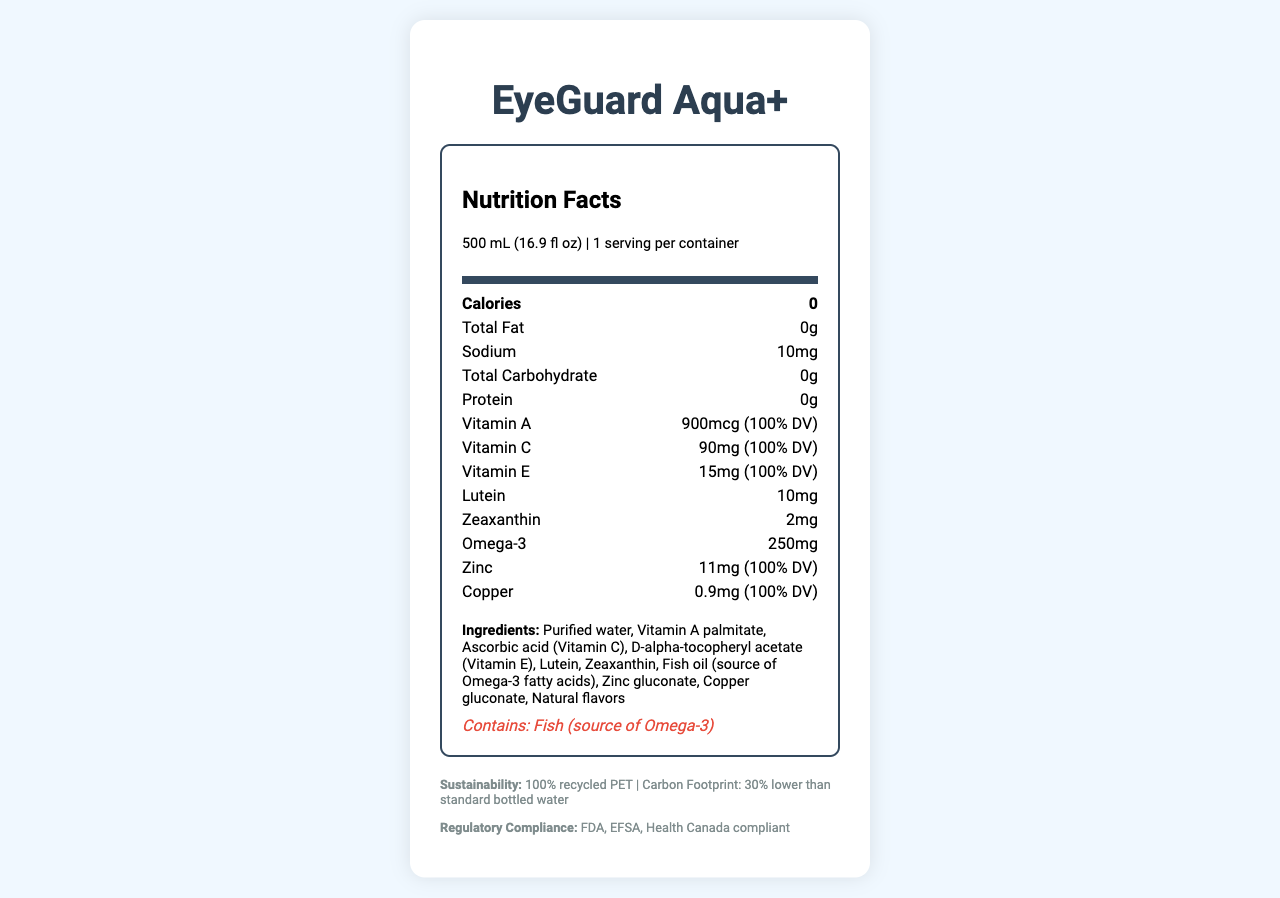what is the serving size of EyeGuard Aqua+? The serving size is listed at the top of the nutrition label under "Nutrition Facts."
Answer: 500 mL (16.9 fl oz) how many calories are in a serving of EyeGuard Aqua+? The calories are listed as "0" in the nutrition label, in the first bold nutrient row.
Answer: 0 what ingredients are used in EyeGuard Aqua+? The ingredients are listed towards the bottom of the nutrition label under the "Ingredients" section.
Answer: Purified water, Vitamin A palmitate, Ascorbic acid (Vitamin C), D-alpha-tocopheryl acetate (Vitamin E), Lutein, Zeaxanthin, Fish oil (source of Omega-3 fatty acids), Zinc gluconate, Copper gluconate, Natural flavors what is the daily value percentage of Vitamin A in EyeGuard Aqua+? The daily value percentage of Vitamin A is provided as "100% DV" in the nutrient rows.
Answer: 100% how much protein is in a serving of EyeGuard Aqua+? The protein content is listed in the nutrition label as "0g."
Answer: 0g which nutrient is present in the highest quantity out of Vitamin C, Lutein, and Omega-3? A. Vitamin C B. Lutein C. Omega-3 Vitamin C is 90mg, Lutein is 10mg, and Omega-3 is 250mg. Therefore, Omega-3 is present in the highest quantity.
Answer: C. Omega-3 what is the amount of sodium in EyeGuard Aqua+? The sodium content is listed as "10mg" in the nutrition label.
Answer: 10mg is EyeGuard Aqua+ compliant with FDA guidelines for nutrient content claims? The extra information section at the bottom of the document indicates that the product meets FDA guidelines.
Answer: Yes does EyeGuard Aqua+ contain any allergens? The allergen information near the ingredients section states that the product contains fish from Omega-3.
Answer: Yes based on the document, can you determine the expiration date of EyeGuard Aqua+? The document does not include any information about the expiration date or how it is calculated.
Answer: Not enough information describe the primary purpose and nutritional benefits of EyeGuard Aqua+. The product description, nutritional information, ingredients list, and sustainability details outline the purpose and benefits of EyeGuard Aqua+.
Answer: EyeGuard Aqua+ is a vitamin-fortified bottled water aimed at promoting eye health and reducing screen fatigue. It contains essential nutrients like Vitamin A, Vitamin C, Vitamin E, Lutein, Zeaxanthin, Omega-3, Zinc, and Copper, which all contribute to eye health. It has zero calories, total fat, total carbohydrate, and protein per serving. The product complies with regulatory requirements in the USA, Europe, and Canada and comes in a 500 mL bottle that is made from 100% recycled PET with a 30% lower carbon footprint than standard bottled water. what material is EyeGuard Aqua+ bottle made from? The sustainability info section states that the bottle material is 100% recycled PET.
Answer: 100% recycled PET 